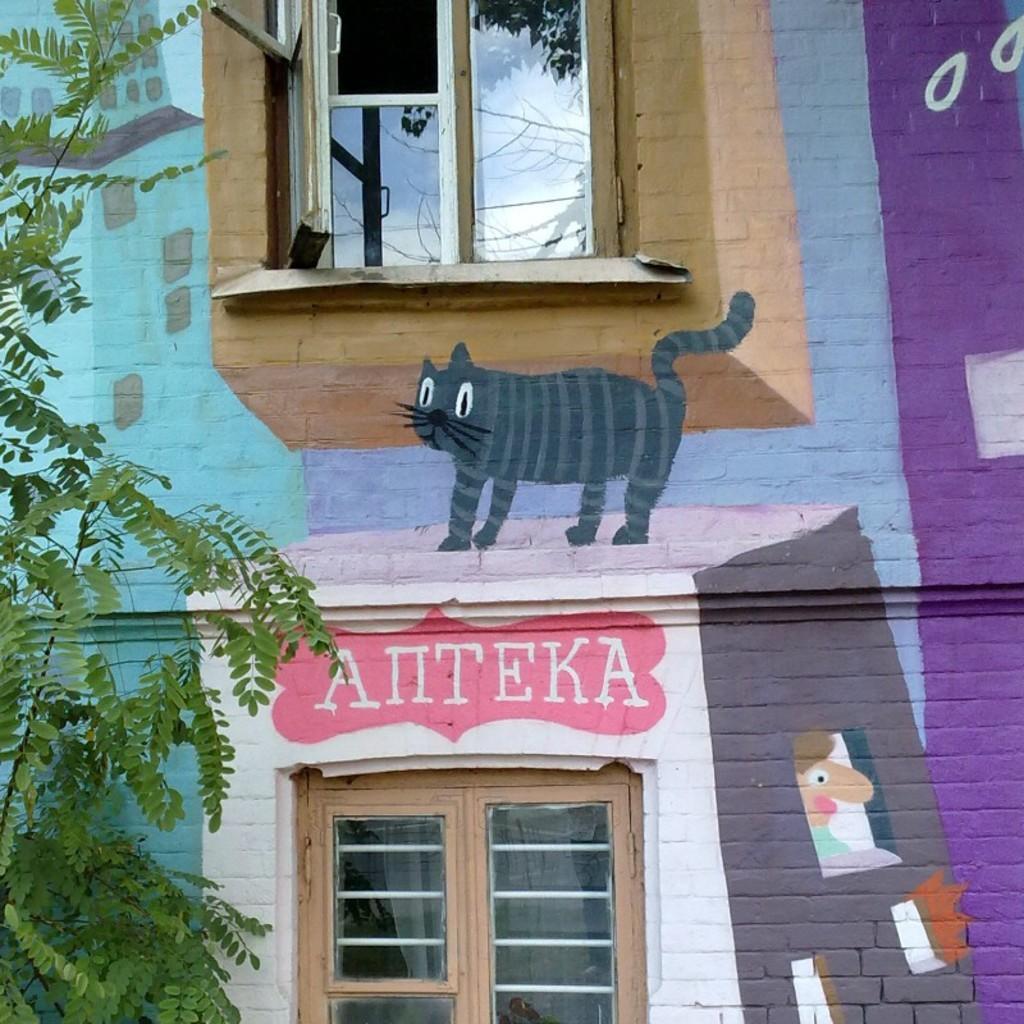How would you summarize this image in a sentence or two? On the left side of the image there is a tree. There is a painting and a text on the building. 